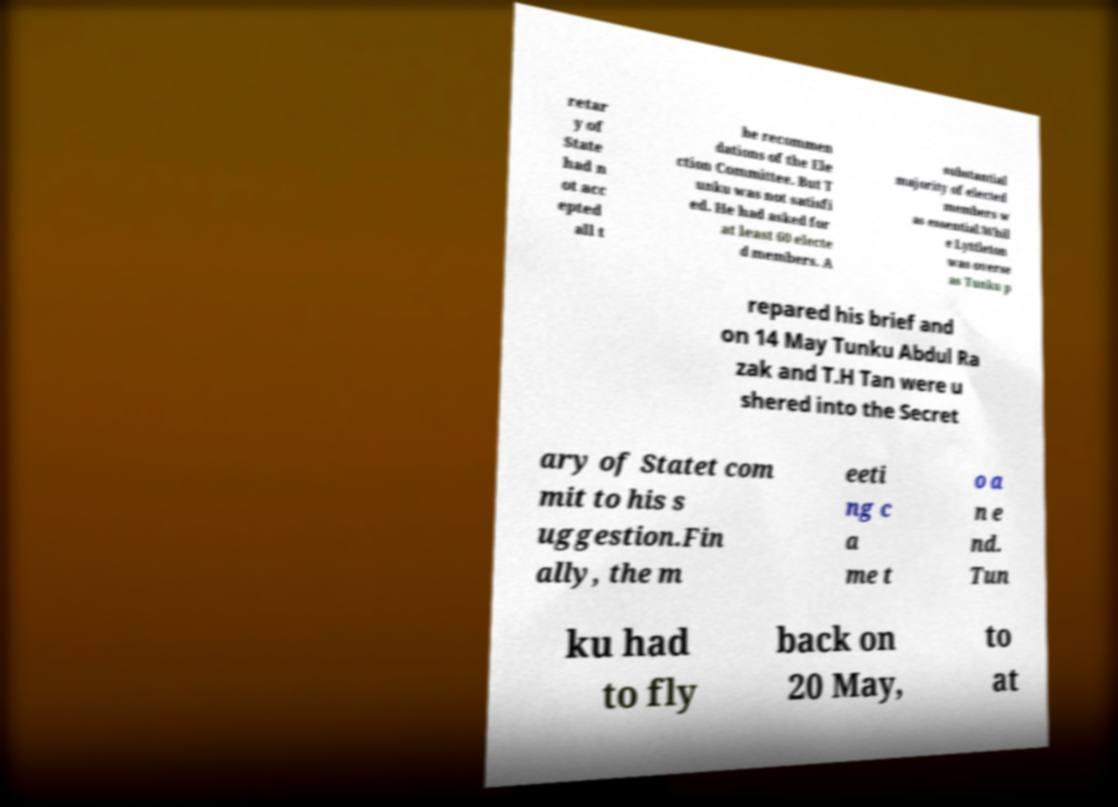What messages or text are displayed in this image? I need them in a readable, typed format. retar y of State had n ot acc epted all t he recommen dations of the Ele ction Committee. But T unku was not satisfi ed. He had asked for at least 60 electe d members. A substantial majority of elected members w as essential.Whil e Lyttleton was overse as Tunku p repared his brief and on 14 May Tunku Abdul Ra zak and T.H Tan were u shered into the Secret ary of Statet com mit to his s uggestion.Fin ally, the m eeti ng c a me t o a n e nd. Tun ku had to fly back on 20 May, to at 